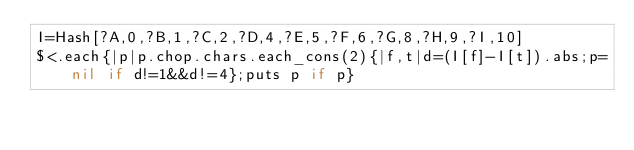Convert code to text. <code><loc_0><loc_0><loc_500><loc_500><_Ruby_>I=Hash[?A,0,?B,1,?C,2,?D,4,?E,5,?F,6,?G,8,?H,9,?I,10]
$<.each{|p|p.chop.chars.each_cons(2){|f,t|d=(I[f]-I[t]).abs;p=nil if d!=1&&d!=4};puts p if p}</code> 